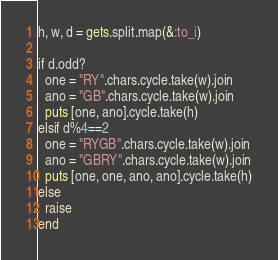<code> <loc_0><loc_0><loc_500><loc_500><_Ruby_>h, w, d = gets.split.map(&:to_i)

if d.odd?
  one = "RY".chars.cycle.take(w).join
  ano = "GB".chars.cycle.take(w).join
  puts [one, ano].cycle.take(h)
elsif d%4==2
  one = "RYGB".chars.cycle.take(w).join
  ano = "GBRY".chars.cycle.take(w).join
  puts [one, one, ano, ano].cycle.take(h)
else
  raise
end</code> 